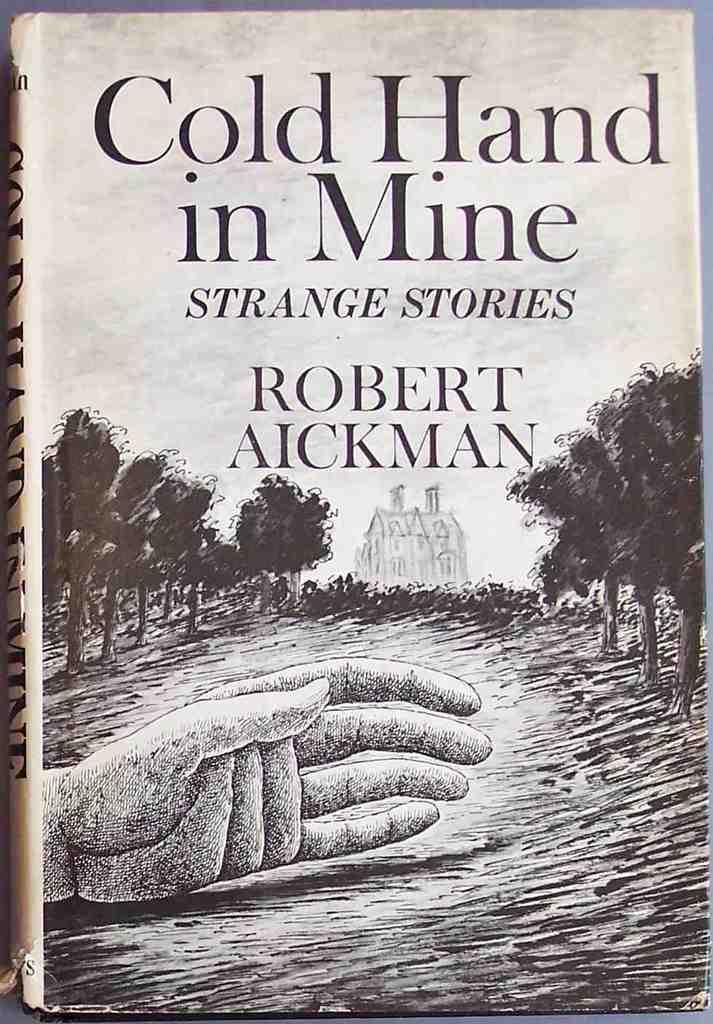Provide a one-sentence caption for the provided image. The book is called Cold Hand in Mine and appears to be about strange stories. 